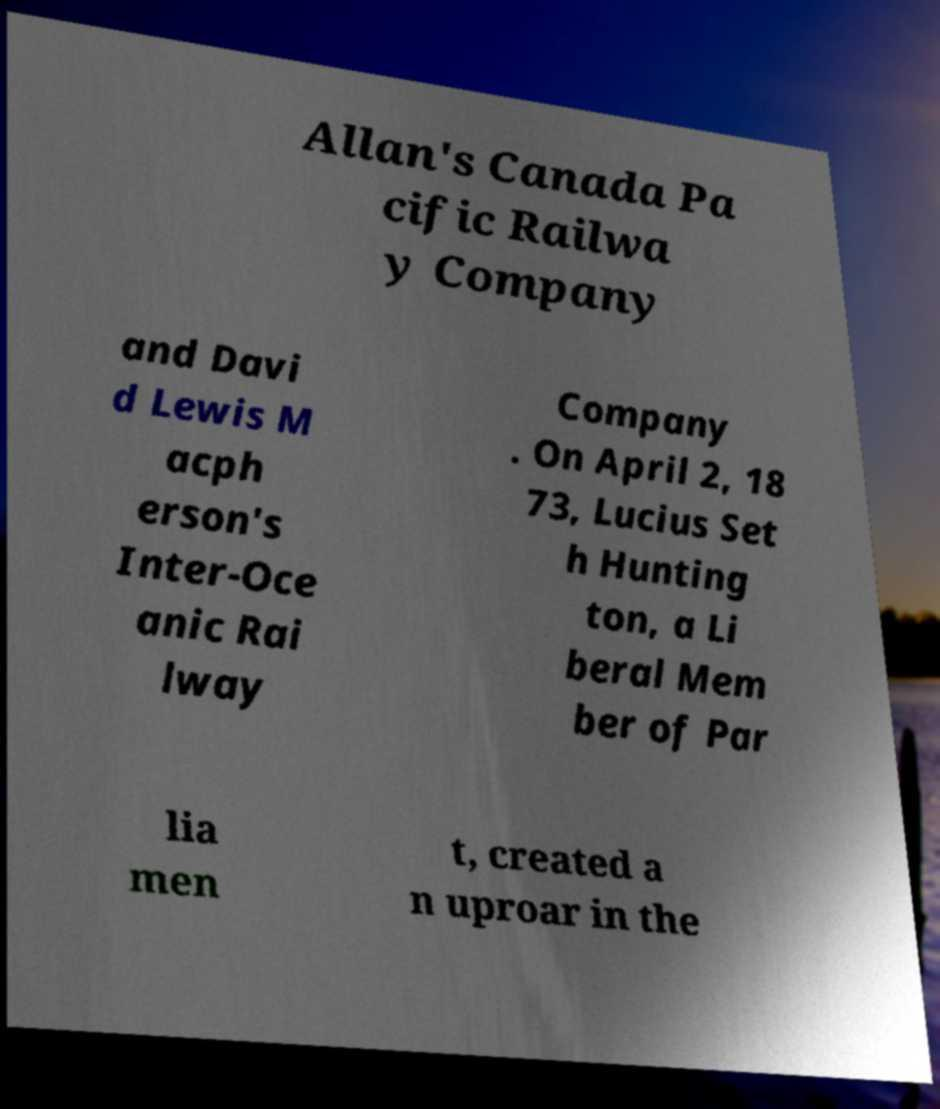Can you accurately transcribe the text from the provided image for me? Allan's Canada Pa cific Railwa y Company and Davi d Lewis M acph erson's Inter-Oce anic Rai lway Company . On April 2, 18 73, Lucius Set h Hunting ton, a Li beral Mem ber of Par lia men t, created a n uproar in the 